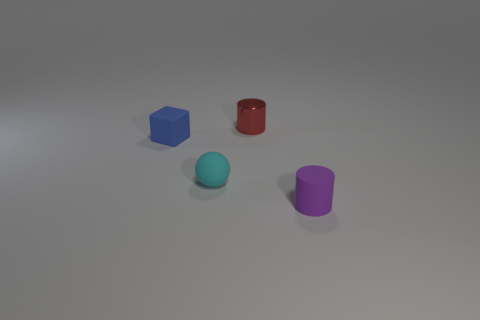Are there fewer tiny cyan things left of the tiny matte sphere than green cylinders? Upon reviewing the image, it's evident that there are no green cylinders present. Therefore, the answer to whether there are fewer tiny cyan things to the left of the tiny matte sphere than green cylinders is that it's not a valid comparison since there are no green cylinders to compare with. The image contains one tiny cyan matte sphere, one tiny blue cube, and two cylinders—one red and one purple. 